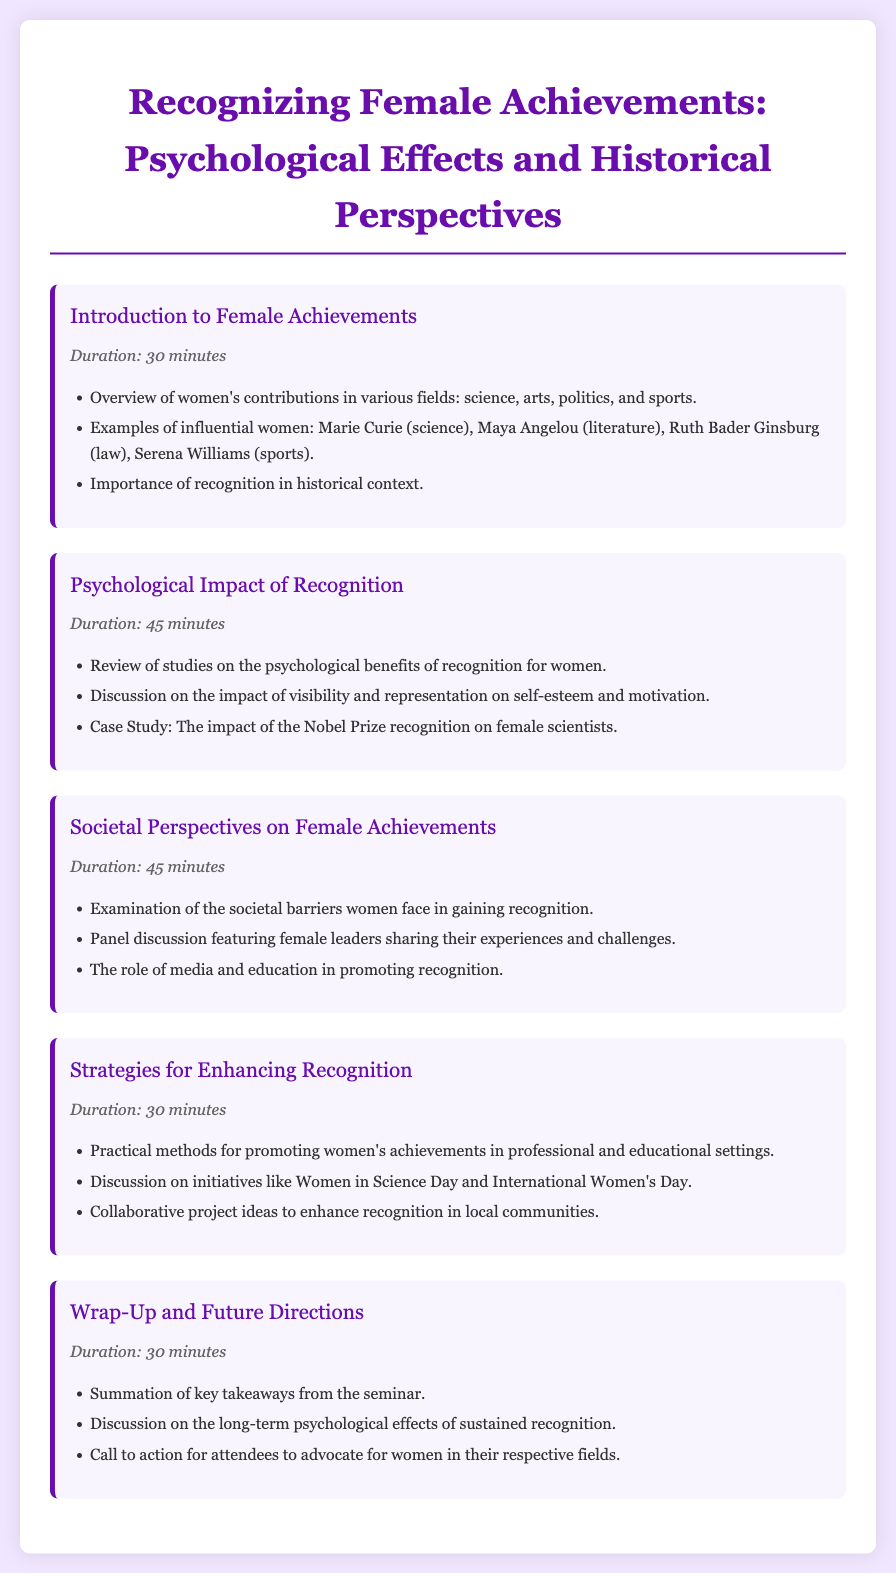what is the title of the seminar? The title of the seminar is provided at the top of the document.
Answer: Recognizing Female Achievements: Psychological Effects and Historical Perspectives how long is the session on Psychological Impact of Recognition? The session duration is listed next to the session title in the document.
Answer: 45 minutes which influential woman is mentioned in the session Introduction to Female Achievements? The document lists notable women in the introduction session.
Answer: Marie Curie what is a case study topic discussed in the seminar? The document mentions specific topics for each session, including case studies.
Answer: The impact of the Nobel Prize recognition on female scientists what is one of the initiatives discussed in the Strategies for Enhancing Recognition session? Initiatives are highlighted in the strategies session, indicating efforts for recognition.
Answer: Women in Science Day who are the participants in the panel discussion of the Societal Perspectives on Female Achievements session? The document describes the type of discussion that will occur during this session.
Answer: Female leaders what is the purpose of the Wrap-Up and Future Directions session? The document states the goals of wrapping up the seminar and future considerations.
Answer: Summation of key takeaways what color is used for the session titles? The color is specified in the style section for the session titles.
Answer: #6a0dad 